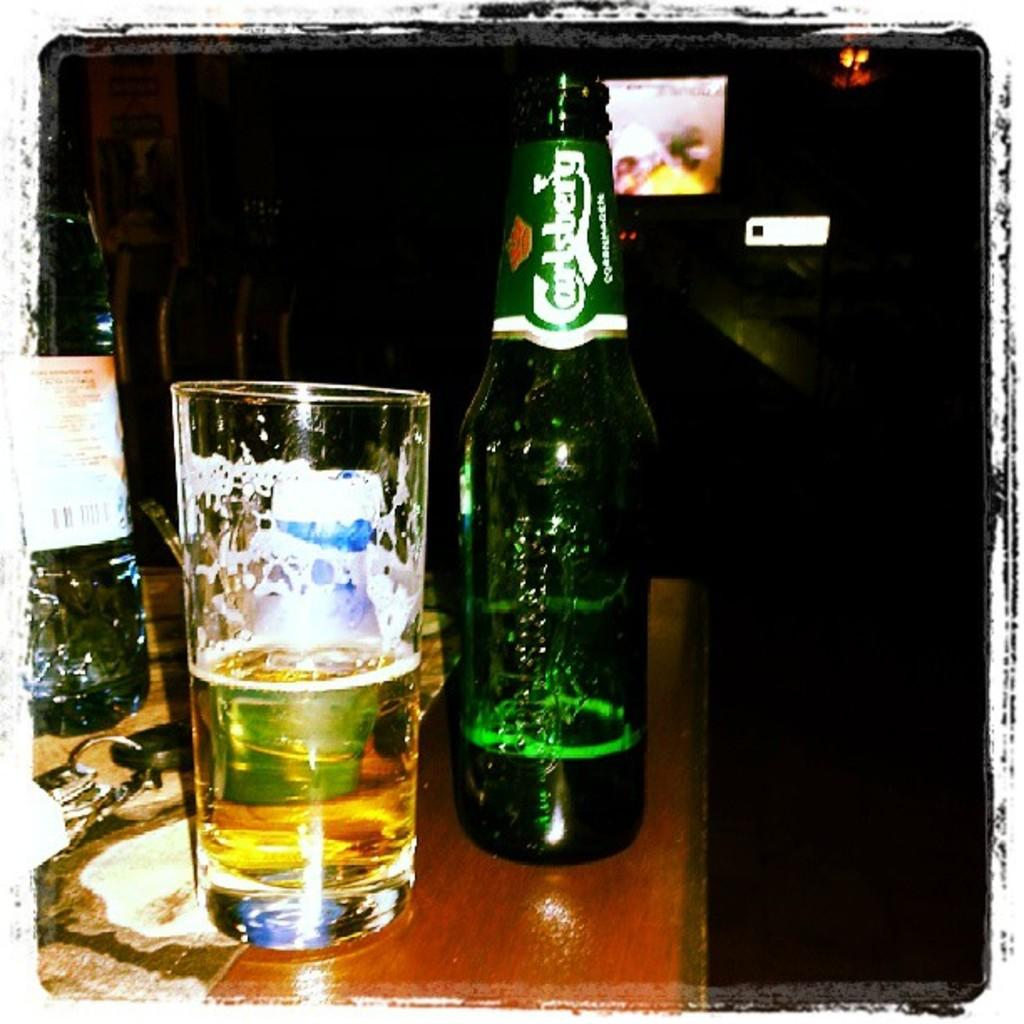<image>
Create a compact narrative representing the image presented. A bottle of Carlsberg beer is poured into a glass. 